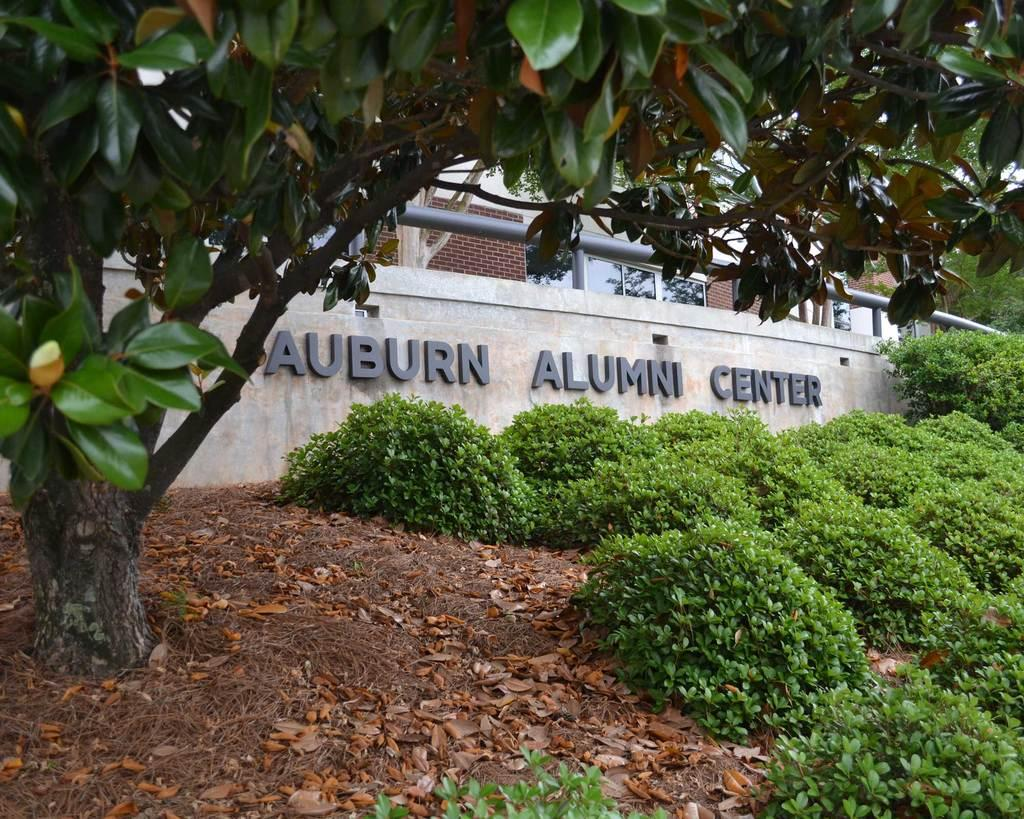What type of structure is visible in the image? There is a building in the image. What can be seen on the wall of the building? There is text on the wall of the building. What type of vegetation is present in front of the building? There are trees and plants in front of the building. What is present on the surface in front of the building? Dry leaves are present on the surface in front of the building. What type of reaction does the uncle have to the request in the image? There is no uncle or request present in the image. 